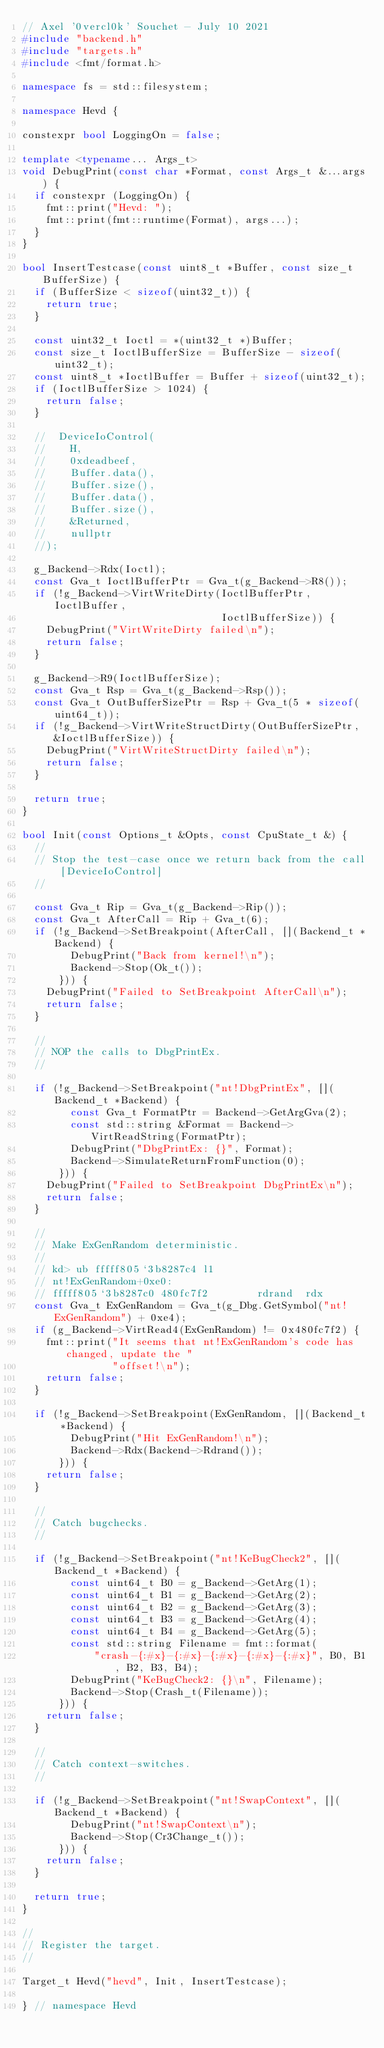<code> <loc_0><loc_0><loc_500><loc_500><_C++_>// Axel '0vercl0k' Souchet - July 10 2021
#include "backend.h"
#include "targets.h"
#include <fmt/format.h>

namespace fs = std::filesystem;

namespace Hevd {

constexpr bool LoggingOn = false;

template <typename... Args_t>
void DebugPrint(const char *Format, const Args_t &...args) {
  if constexpr (LoggingOn) {
    fmt::print("Hevd: ");
    fmt::print(fmt::runtime(Format), args...);
  }
}

bool InsertTestcase(const uint8_t *Buffer, const size_t BufferSize) {
  if (BufferSize < sizeof(uint32_t)) {
    return true;
  }

  const uint32_t Ioctl = *(uint32_t *)Buffer;
  const size_t IoctlBufferSize = BufferSize - sizeof(uint32_t);
  const uint8_t *IoctlBuffer = Buffer + sizeof(uint32_t);
  if (IoctlBufferSize > 1024) {
    return false;
  }

  //  DeviceIoControl(
  //    H,
  //    0xdeadbeef,
  //    Buffer.data(),
  //    Buffer.size(),
  //    Buffer.data(),
  //    Buffer.size(),
  //    &Returned,
  //    nullptr
  //);

  g_Backend->Rdx(Ioctl);
  const Gva_t IoctlBufferPtr = Gva_t(g_Backend->R8());
  if (!g_Backend->VirtWriteDirty(IoctlBufferPtr, IoctlBuffer,
                                 IoctlBufferSize)) {
    DebugPrint("VirtWriteDirty failed\n");
    return false;
  }

  g_Backend->R9(IoctlBufferSize);
  const Gva_t Rsp = Gva_t(g_Backend->Rsp());
  const Gva_t OutBufferSizePtr = Rsp + Gva_t(5 * sizeof(uint64_t));
  if (!g_Backend->VirtWriteStructDirty(OutBufferSizePtr, &IoctlBufferSize)) {
    DebugPrint("VirtWriteStructDirty failed\n");
    return false;
  }

  return true;
}

bool Init(const Options_t &Opts, const CpuState_t &) {
  //
  // Stop the test-case once we return back from the call [DeviceIoControl]
  //

  const Gva_t Rip = Gva_t(g_Backend->Rip());
  const Gva_t AfterCall = Rip + Gva_t(6);
  if (!g_Backend->SetBreakpoint(AfterCall, [](Backend_t *Backend) {
        DebugPrint("Back from kernel!\n");
        Backend->Stop(Ok_t());
      })) {
    DebugPrint("Failed to SetBreakpoint AfterCall\n");
    return false;
  }

  //
  // NOP the calls to DbgPrintEx.
  //

  if (!g_Backend->SetBreakpoint("nt!DbgPrintEx", [](Backend_t *Backend) {
        const Gva_t FormatPtr = Backend->GetArgGva(2);
        const std::string &Format = Backend->VirtReadString(FormatPtr);
        DebugPrint("DbgPrintEx: {}", Format);
        Backend->SimulateReturnFromFunction(0);
      })) {
    DebugPrint("Failed to SetBreakpoint DbgPrintEx\n");
    return false;
  }

  //
  // Make ExGenRandom deterministic.
  //
  // kd> ub fffff805`3b8287c4 l1
  // nt!ExGenRandom+0xe0:
  // fffff805`3b8287c0 480fc7f2        rdrand  rdx
  const Gva_t ExGenRandom = Gva_t(g_Dbg.GetSymbol("nt!ExGenRandom") + 0xe4);
  if (g_Backend->VirtRead4(ExGenRandom) != 0x480fc7f2) {
    fmt::print("It seems that nt!ExGenRandom's code has changed, update the "
               "offset!\n");
    return false;
  }

  if (!g_Backend->SetBreakpoint(ExGenRandom, [](Backend_t *Backend) {
        DebugPrint("Hit ExGenRandom!\n");
        Backend->Rdx(Backend->Rdrand());
      })) {
    return false;
  }

  //
  // Catch bugchecks.
  //

  if (!g_Backend->SetBreakpoint("nt!KeBugCheck2", [](Backend_t *Backend) {
        const uint64_t B0 = g_Backend->GetArg(1);
        const uint64_t B1 = g_Backend->GetArg(2);
        const uint64_t B2 = g_Backend->GetArg(3);
        const uint64_t B3 = g_Backend->GetArg(4);
        const uint64_t B4 = g_Backend->GetArg(5);
        const std::string Filename = fmt::format(
            "crash-{:#x}-{:#x}-{:#x}-{:#x}-{:#x}", B0, B1, B2, B3, B4);
        DebugPrint("KeBugCheck2: {}\n", Filename);
        Backend->Stop(Crash_t(Filename));
      })) {
    return false;
  }

  //
  // Catch context-switches.
  //

  if (!g_Backend->SetBreakpoint("nt!SwapContext", [](Backend_t *Backend) {
        DebugPrint("nt!SwapContext\n");
        Backend->Stop(Cr3Change_t());
      })) {
    return false;
  }

  return true;
}

//
// Register the target.
//

Target_t Hevd("hevd", Init, InsertTestcase);

} // namespace Hevd</code> 